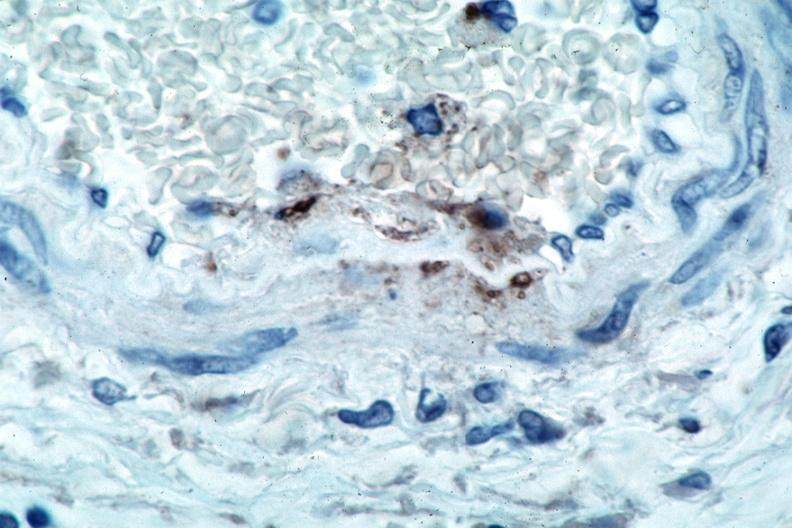what is present?
Answer the question using a single word or phrase. Vasculature 